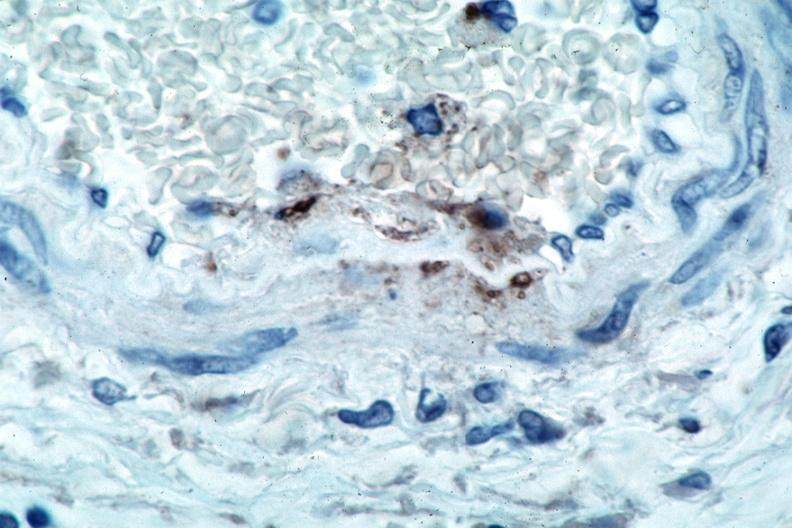what is present?
Answer the question using a single word or phrase. Vasculature 